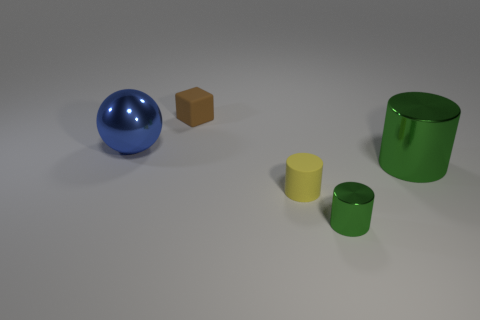Subtract all blue cubes. Subtract all blue balls. How many cubes are left? 1 Add 3 big green things. How many objects exist? 8 Subtract all blocks. How many objects are left? 4 Subtract 0 green balls. How many objects are left? 5 Subtract all large green metal objects. Subtract all small rubber things. How many objects are left? 2 Add 5 yellow matte things. How many yellow matte things are left? 6 Add 5 big green metal objects. How many big green metal objects exist? 6 